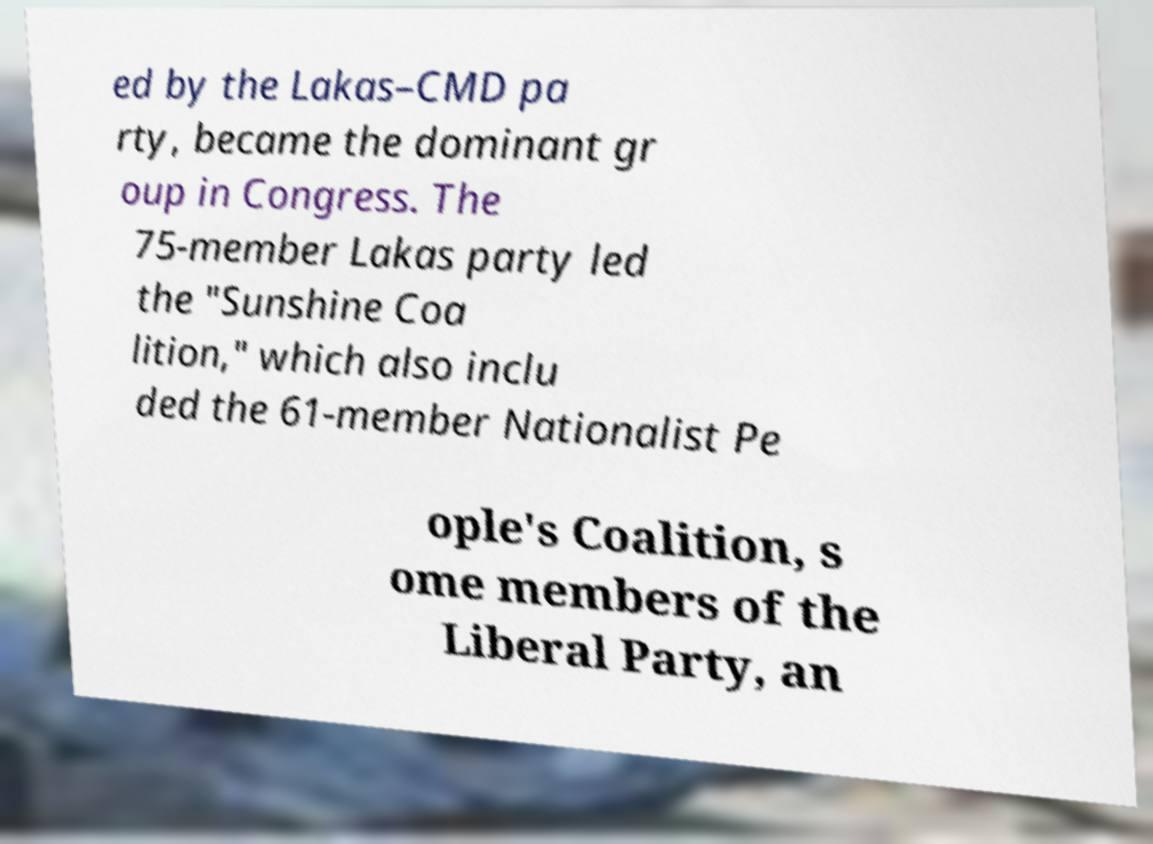Can you read and provide the text displayed in the image?This photo seems to have some interesting text. Can you extract and type it out for me? ed by the Lakas–CMD pa rty, became the dominant gr oup in Congress. The 75-member Lakas party led the "Sunshine Coa lition," which also inclu ded the 61-member Nationalist Pe ople's Coalition, s ome members of the Liberal Party, an 